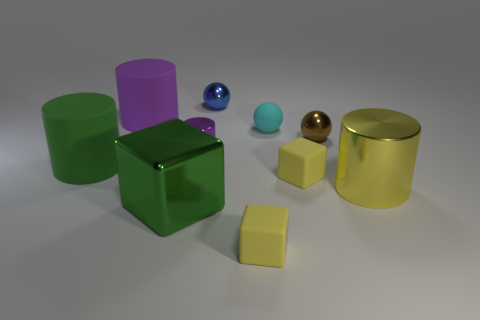Subtract all tiny blue spheres. How many spheres are left? 2 Subtract all blue cylinders. How many yellow cubes are left? 2 Subtract all yellow cylinders. How many cylinders are left? 3 Subtract all cylinders. How many objects are left? 6 Subtract 2 cylinders. How many cylinders are left? 2 Subtract 2 purple cylinders. How many objects are left? 8 Subtract all brown cylinders. Subtract all purple spheres. How many cylinders are left? 4 Subtract all large purple rubber things. Subtract all big yellow cylinders. How many objects are left? 8 Add 8 purple cylinders. How many purple cylinders are left? 10 Add 3 big things. How many big things exist? 7 